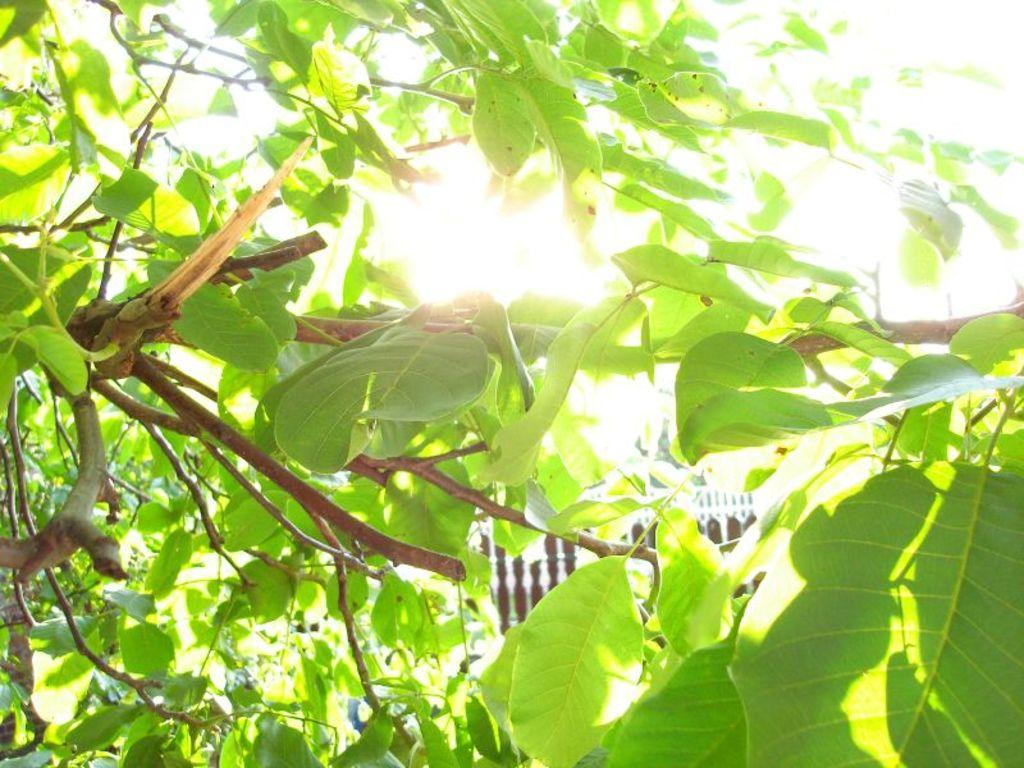What type of plant can be seen in the image? There is a tree in the image. What is the color of the leaves on the tree? The tree has green leaves. What material is the railing made of in the image? The railing in the image is made of wood. What can be seen in the background of the image? The sun is visible in the background of the image. How many rabbits are hopping around the tree in the image? There are no rabbits present in the image; it only features a tree with green leaves and a wooden railing. What type of power source is used to generate electricity in the image? There is no mention of a power source or electricity in the image; it only features a tree, green leaves, a wooden railing, and the sun in the background. 